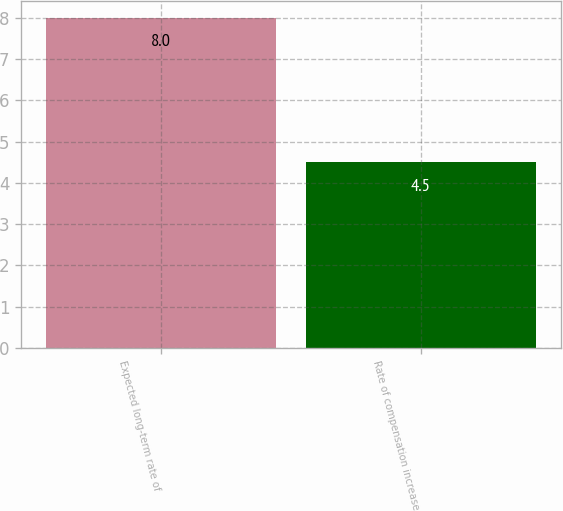Convert chart. <chart><loc_0><loc_0><loc_500><loc_500><bar_chart><fcel>Expected long-term rate of<fcel>Rate of compensation increase<nl><fcel>8<fcel>4.5<nl></chart> 